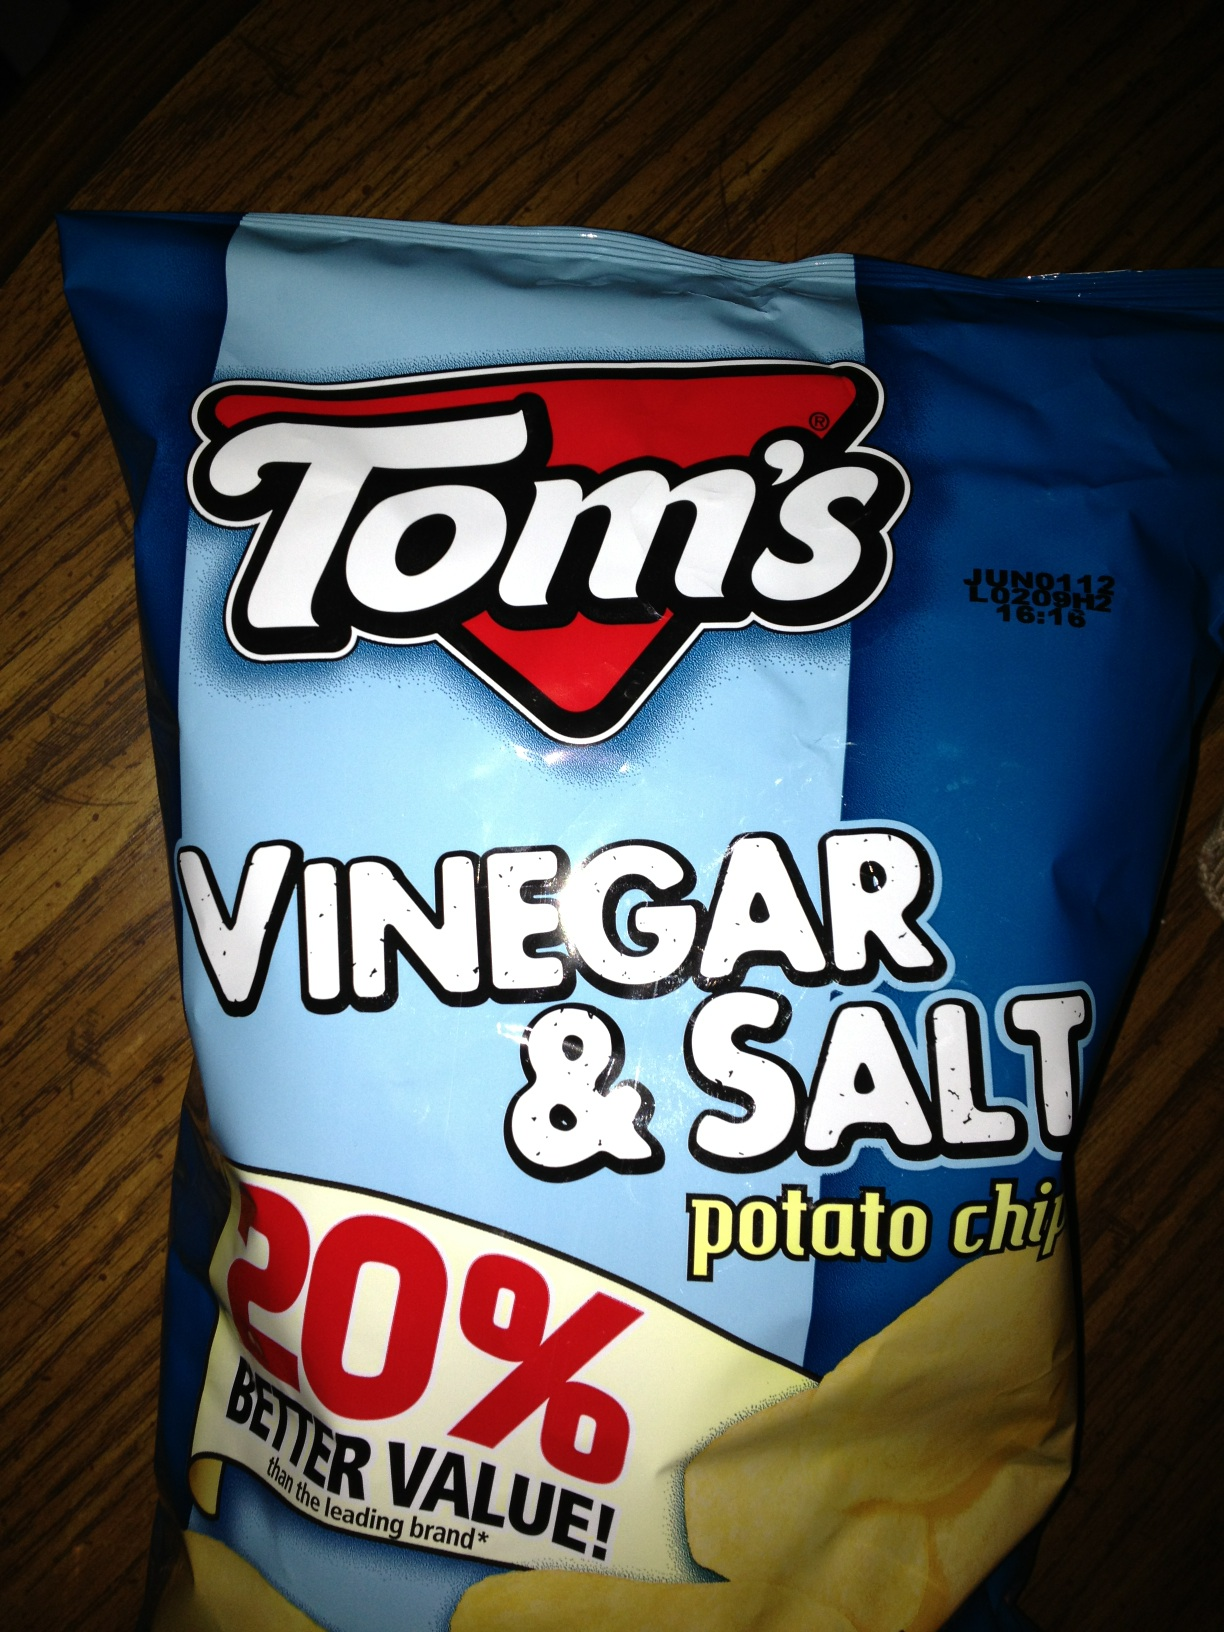Can you describe the flavor profile of these chips? Certainly! Tom's Vinegar & Salt potato chips offer a sharp, tangy taste from the vinegar balanced with the savory and slightly sweet flavor of salt. The combination provides a mouth-watering contrast that tantalizes your taste buds with each crisp bite. How can these chips be incorporated into a meal? Tom's Vinegar & Salt potato chips can be a zesty crunch addition to your meal. You can crumble them over a salad for an extra tang, use them as a flavorful coating for baked chicken tenders, or pair them with a sandwich for a satisfying snack. The bold taste complements a variety of dishes, making them a versatile ingredient. 